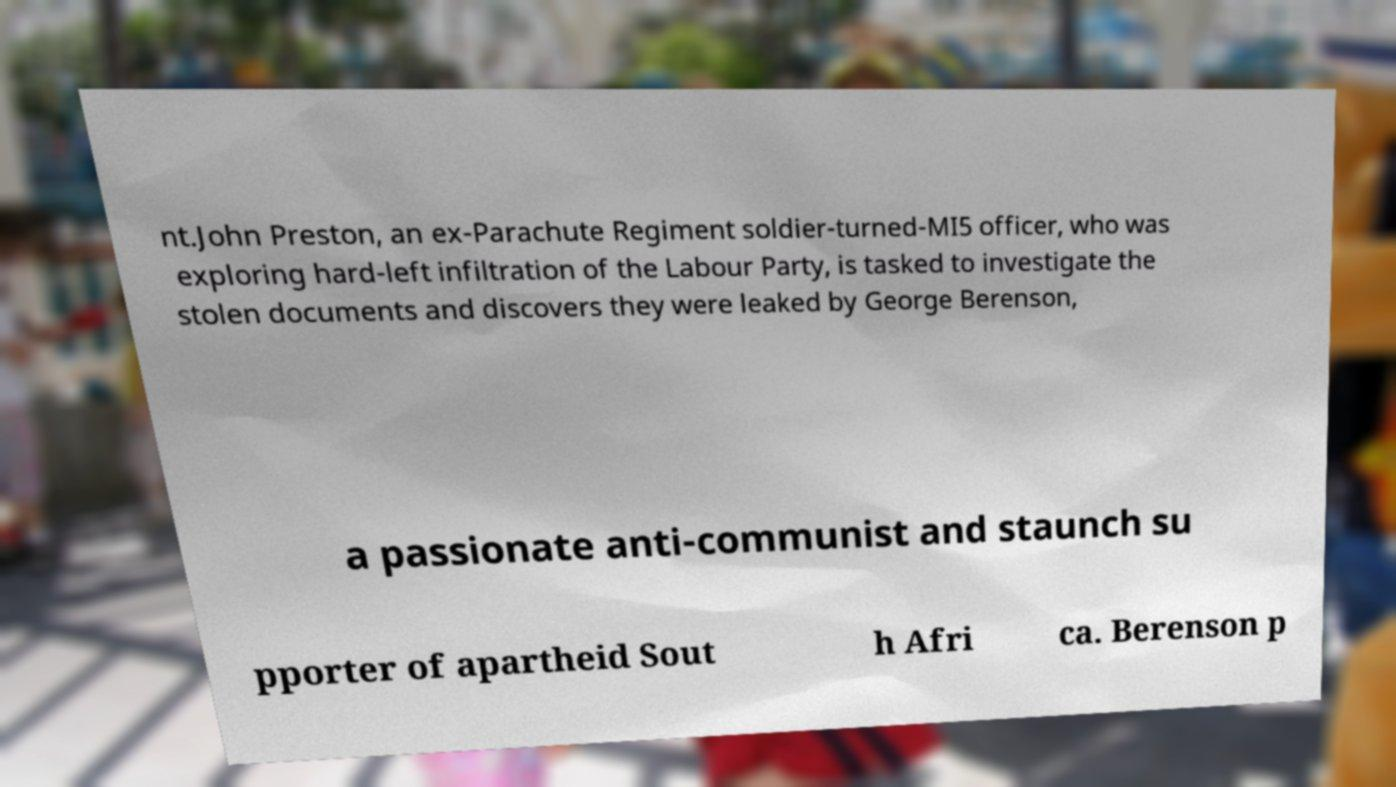Please read and relay the text visible in this image. What does it say? nt.John Preston, an ex-Parachute Regiment soldier-turned-MI5 officer, who was exploring hard-left infiltration of the Labour Party, is tasked to investigate the stolen documents and discovers they were leaked by George Berenson, a passionate anti-communist and staunch su pporter of apartheid Sout h Afri ca. Berenson p 